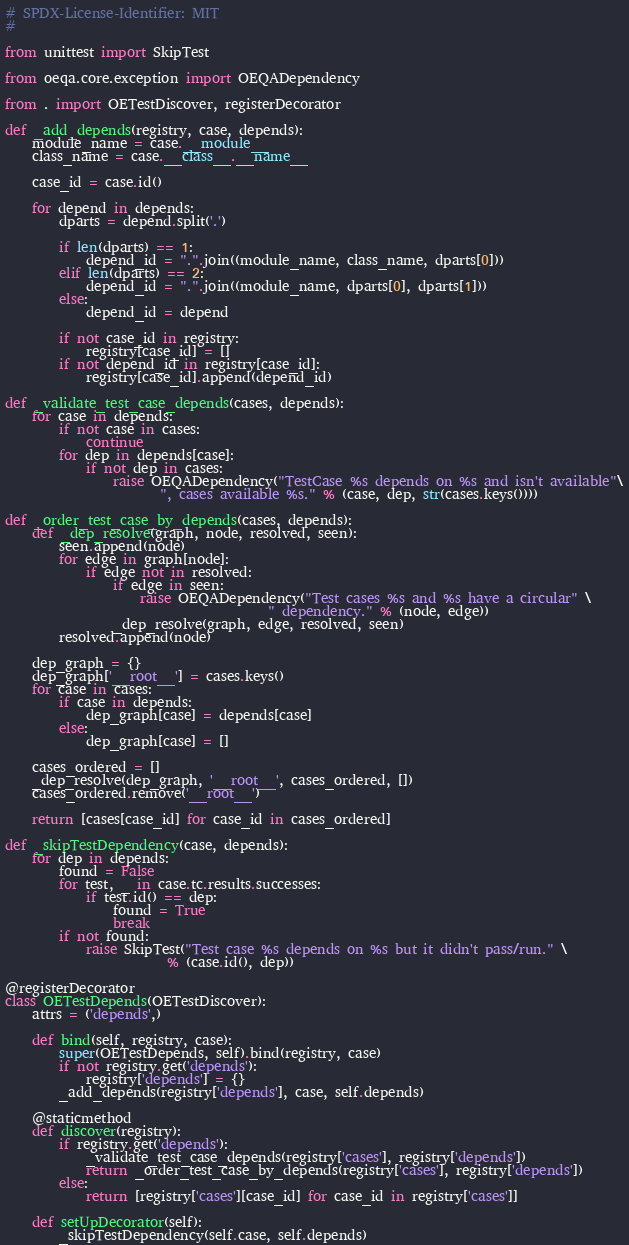<code> <loc_0><loc_0><loc_500><loc_500><_Python_># SPDX-License-Identifier: MIT
#

from unittest import SkipTest

from oeqa.core.exception import OEQADependency

from . import OETestDiscover, registerDecorator

def _add_depends(registry, case, depends):
    module_name = case.__module__
    class_name = case.__class__.__name__

    case_id = case.id()

    for depend in depends:
        dparts = depend.split('.')

        if len(dparts) == 1:
            depend_id = ".".join((module_name, class_name, dparts[0]))
        elif len(dparts) == 2:
            depend_id = ".".join((module_name, dparts[0], dparts[1]))
        else:
            depend_id = depend

        if not case_id in registry:
            registry[case_id] = []
        if not depend_id in registry[case_id]:
            registry[case_id].append(depend_id)

def _validate_test_case_depends(cases, depends):
    for case in depends:
        if not case in cases:
            continue
        for dep in depends[case]:
            if not dep in cases:
                raise OEQADependency("TestCase %s depends on %s and isn't available"\
                       ", cases available %s." % (case, dep, str(cases.keys())))

def _order_test_case_by_depends(cases, depends):
    def _dep_resolve(graph, node, resolved, seen):
        seen.append(node)
        for edge in graph[node]:
            if edge not in resolved:
                if edge in seen:
                    raise OEQADependency("Test cases %s and %s have a circular" \
                                       " dependency." % (node, edge))
                _dep_resolve(graph, edge, resolved, seen)
        resolved.append(node)

    dep_graph = {}
    dep_graph['__root__'] = cases.keys()
    for case in cases:
        if case in depends:
            dep_graph[case] = depends[case]
        else:
            dep_graph[case] = []

    cases_ordered = []
    _dep_resolve(dep_graph, '__root__', cases_ordered, [])
    cases_ordered.remove('__root__')

    return [cases[case_id] for case_id in cases_ordered]

def _skipTestDependency(case, depends):
    for dep in depends:
        found = False
        for test, _ in case.tc.results.successes:
            if test.id() == dep:
                found = True
                break
        if not found:
            raise SkipTest("Test case %s depends on %s but it didn't pass/run." \
                        % (case.id(), dep))

@registerDecorator
class OETestDepends(OETestDiscover):
    attrs = ('depends',)

    def bind(self, registry, case):
        super(OETestDepends, self).bind(registry, case)
        if not registry.get('depends'):
            registry['depends'] = {}
        _add_depends(registry['depends'], case, self.depends)

    @staticmethod
    def discover(registry):
        if registry.get('depends'):
            _validate_test_case_depends(registry['cases'], registry['depends'])
            return _order_test_case_by_depends(registry['cases'], registry['depends'])
        else:
            return [registry['cases'][case_id] for case_id in registry['cases']]

    def setUpDecorator(self):
        _skipTestDependency(self.case, self.depends)
</code> 